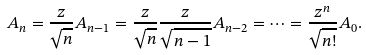<formula> <loc_0><loc_0><loc_500><loc_500>A _ { n } & = \frac { z } { \sqrt { n } } A _ { n - 1 } = \frac { z } { \sqrt { n } } \frac { z } { \sqrt { n - 1 } } A _ { n - 2 } = \cdots = \frac { z ^ { n } } { \sqrt { n ! } } A _ { 0 } .</formula> 